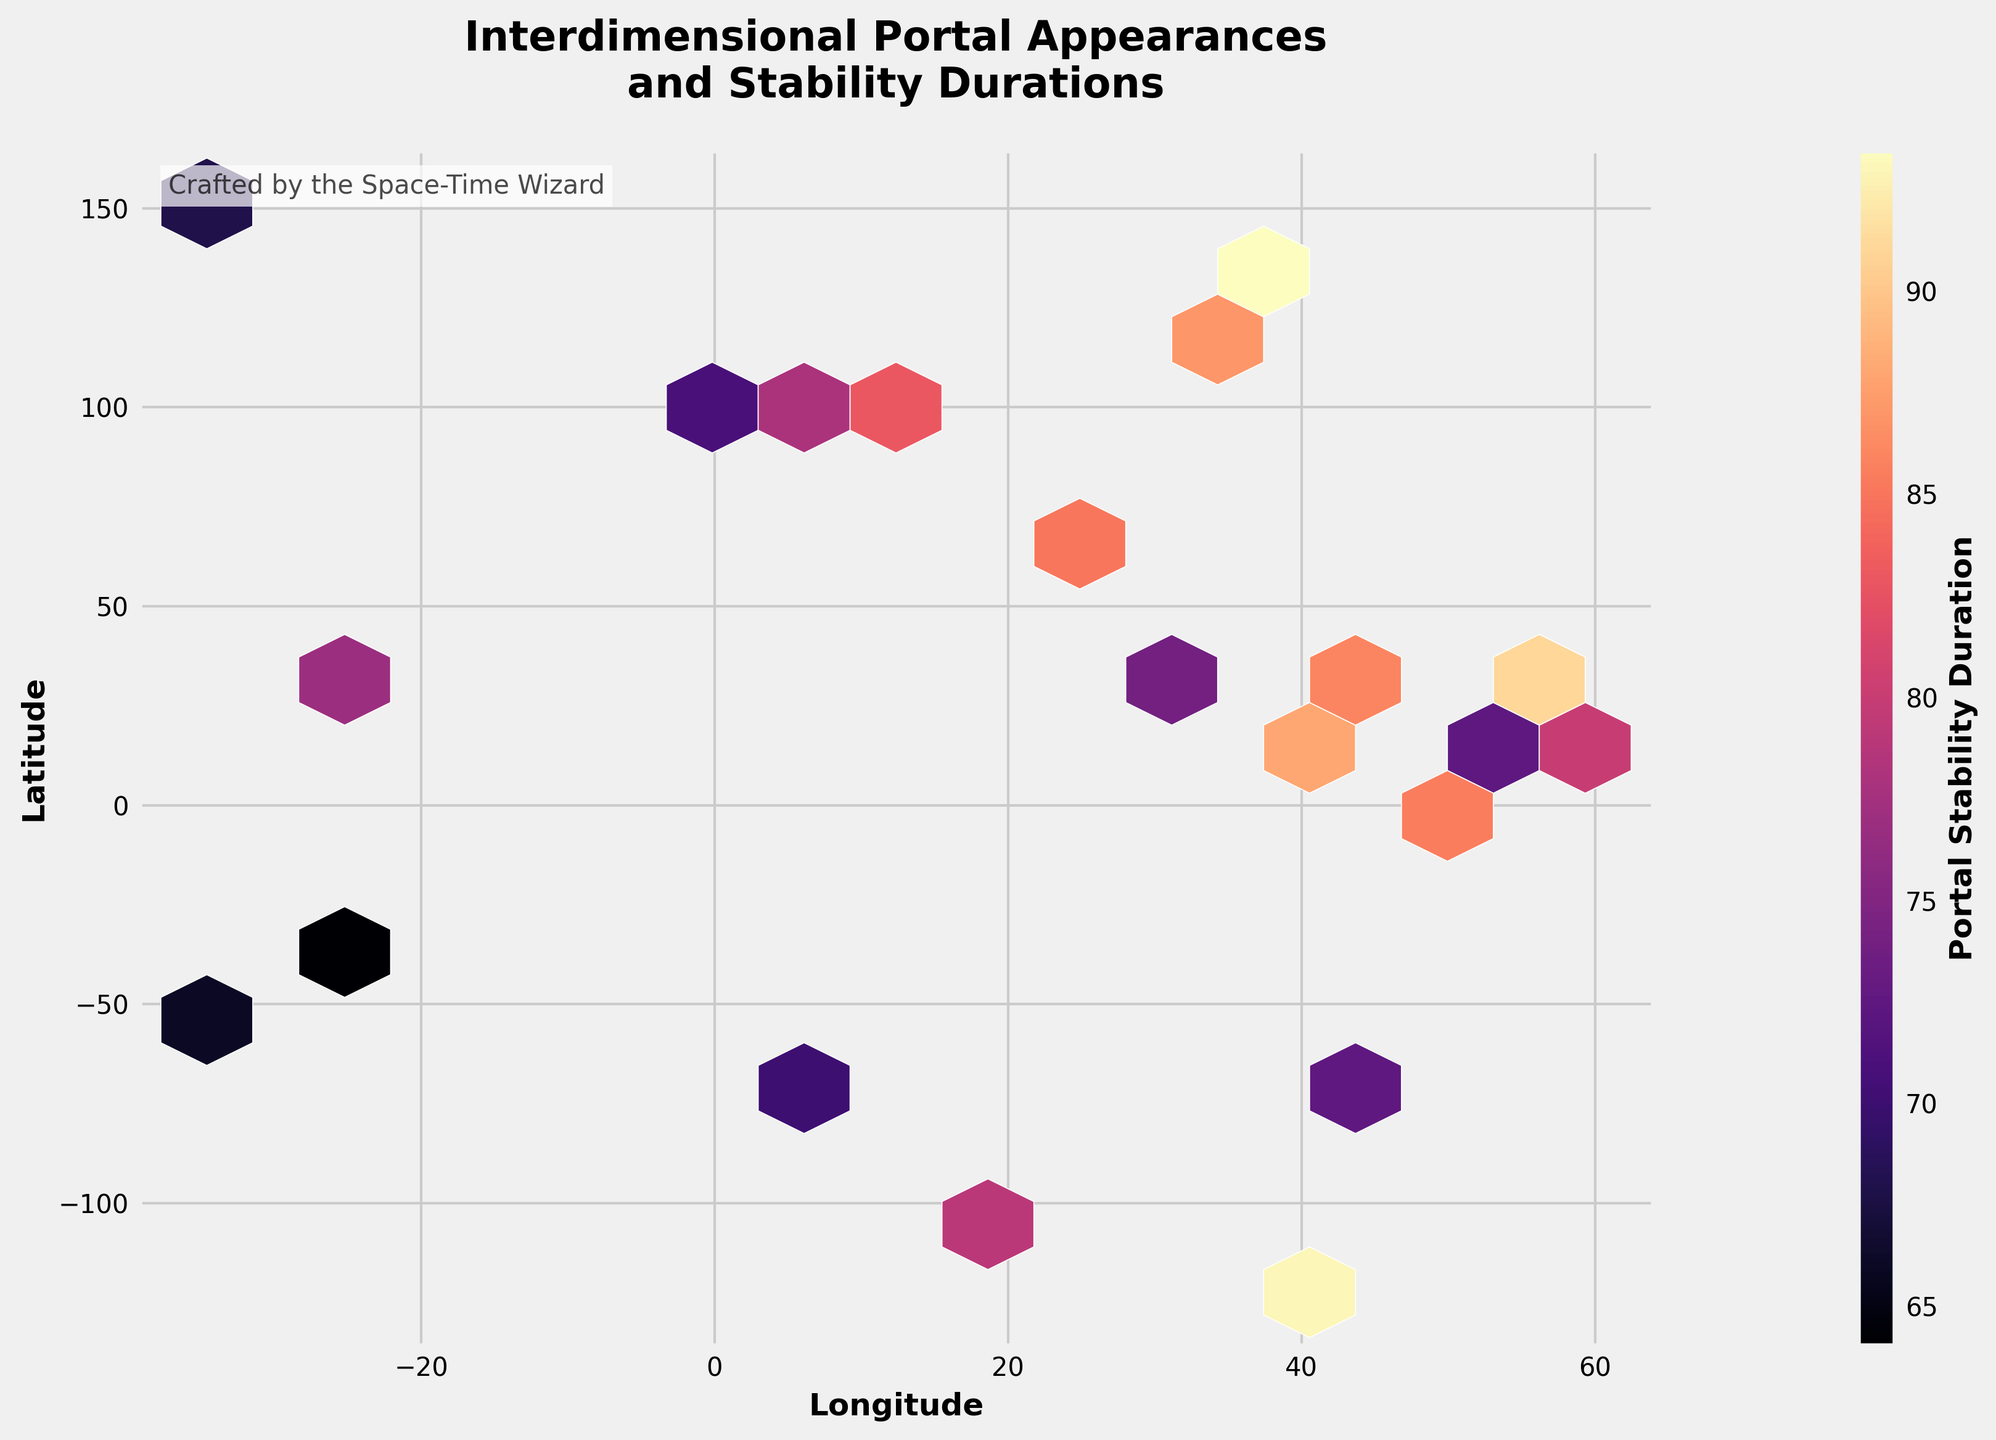what is the title of the figure? The title is displayed at the top center of the figure, showing details about what the plot represents.
Answer: Interdimensional Portal Appearances and Stability Durations Which color represents areas of highest portal stability duration? In the hexbin plot, the color map 'magma' is used, where brighter yellow indicates higher values of portal stability duration.
Answer: Bright yellow What do the x and y axes represent? The x and y axes are labeled to represent geographical coordinates, where the x-axis indicates Longitude and the y-axis indicates Latitude.
Answer: Longitude and Latitude Are there more interdimensional portal appearances around longitude 0 than longitude 100? By examining the hexbin plot, you can compare the density and intensity of the hexagons located around the mentioned longitudes. The area around longitude 0 appears less dense than around 100.
Answer: No What is the stability duration of a portal at (51.5074, -0.1278)? Each hexbin's color represents the stability duration based on the color bar. Locate the point and refer to the color that corresponds to it on the color bar. The portal at these coordinates is indicated by a hexbin with high intensity.
Answer: 89 Which geographical area shows higher portal stability duration, (40, -70) or (48, 2)? Compare the color intensity of the hexagons near these coordinates using the color map. The hexagon around (48, 2) shows a brighter color, indicating higher portal stability duration.
Answer: (48, 2) If two locations have similar longitude but one has a latitude of 20 and the other -20, which appears more stable? Check the hexagons at these coordinates and compare their color intensities. The hexagon around latitude 20 shows a higher intensity compared to the one around -20.
Answer: Latitude 20 How many distinct hexagon clusters can you identify with significant portal appearances and stability durations? By observing the dense areas of hexagons, you can count the distinct clusters where hexagons are densely populated. A detailed look will show around 5 major clusters.
Answer: 5 Is the area around (35, 139) showing one of the highest stability durations? Locate these coordinates on the plot and examine the hexagon's color intensity. This is one of the areas with the highest stability duration, indicated by a bright color.
Answer: Yes 